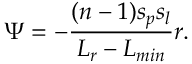<formula> <loc_0><loc_0><loc_500><loc_500>\Psi = - \frac { ( n - 1 ) s _ { p } s _ { l } } { L _ { r } - L _ { \min } } r .</formula> 